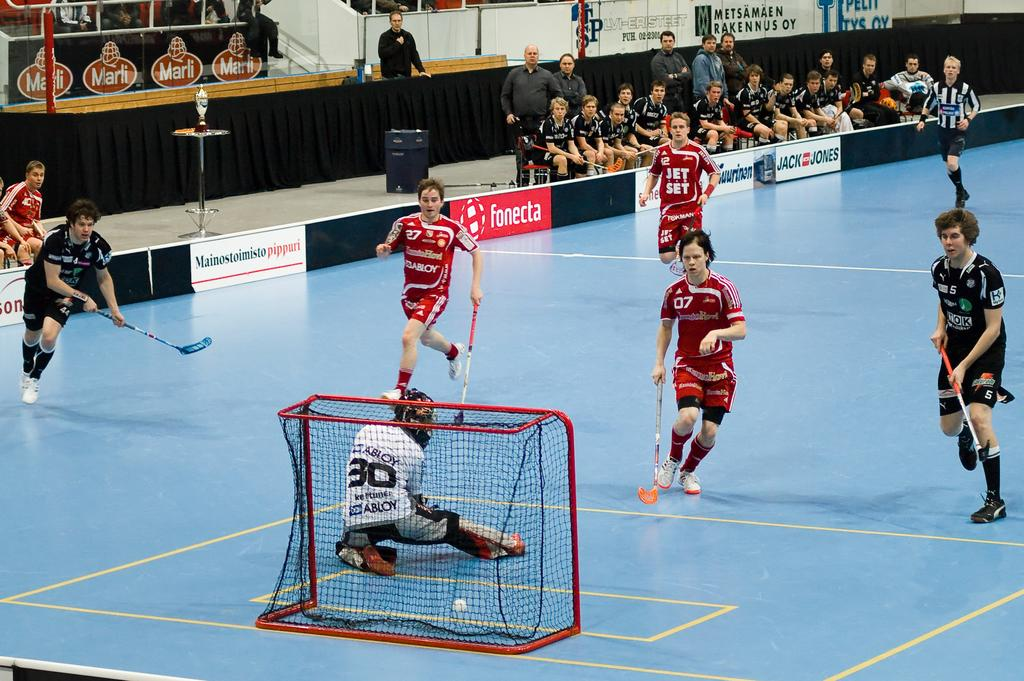Provide a one-sentence caption for the provided image. Abloy is one of the sponsors of the team in red. 